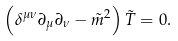Convert formula to latex. <formula><loc_0><loc_0><loc_500><loc_500>\left ( \delta ^ { \mu \nu } \partial _ { \mu } \partial _ { \nu } - \tilde { m } ^ { 2 } \right ) \tilde { T } = 0 .</formula> 